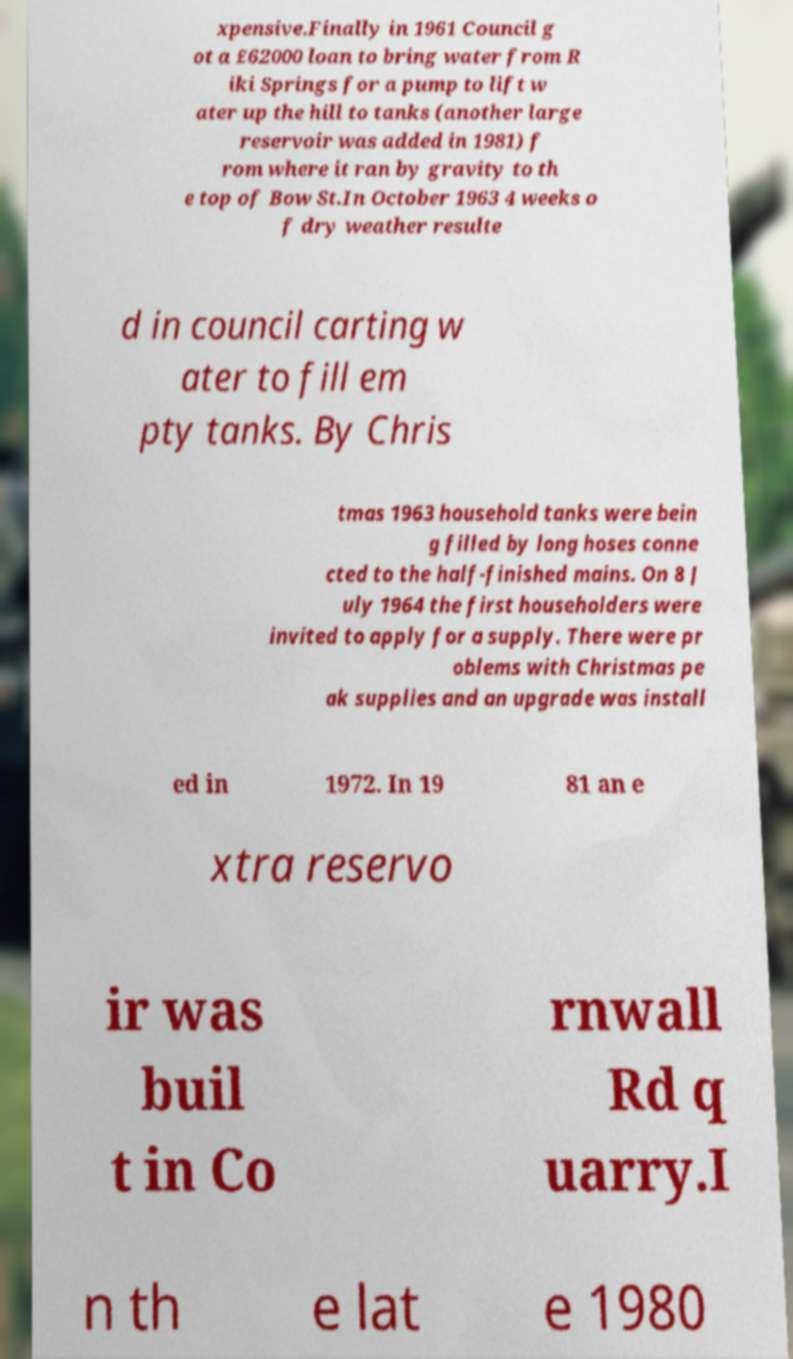Could you extract and type out the text from this image? xpensive.Finally in 1961 Council g ot a £62000 loan to bring water from R iki Springs for a pump to lift w ater up the hill to tanks (another large reservoir was added in 1981) f rom where it ran by gravity to th e top of Bow St.In October 1963 4 weeks o f dry weather resulte d in council carting w ater to fill em pty tanks. By Chris tmas 1963 household tanks were bein g filled by long hoses conne cted to the half-finished mains. On 8 J uly 1964 the first householders were invited to apply for a supply. There were pr oblems with Christmas pe ak supplies and an upgrade was install ed in 1972. In 19 81 an e xtra reservo ir was buil t in Co rnwall Rd q uarry.I n th e lat e 1980 